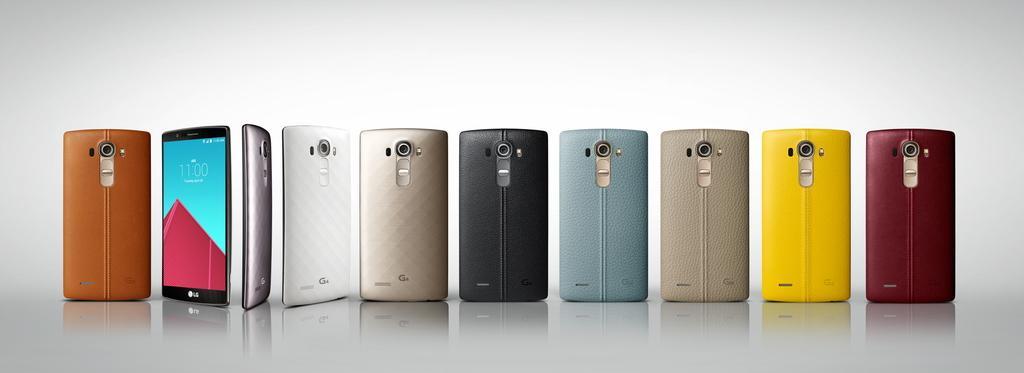In one or two sentences, can you explain what this image depicts? In this image, there are some phones in different colors. 